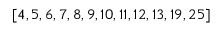<formula> <loc_0><loc_0><loc_500><loc_500>\left [ 4 , 5 , 6 , 7 , 8 , 9 , 1 0 , 1 1 , 1 2 , 1 3 , 1 9 , 2 5 \right ]</formula> 